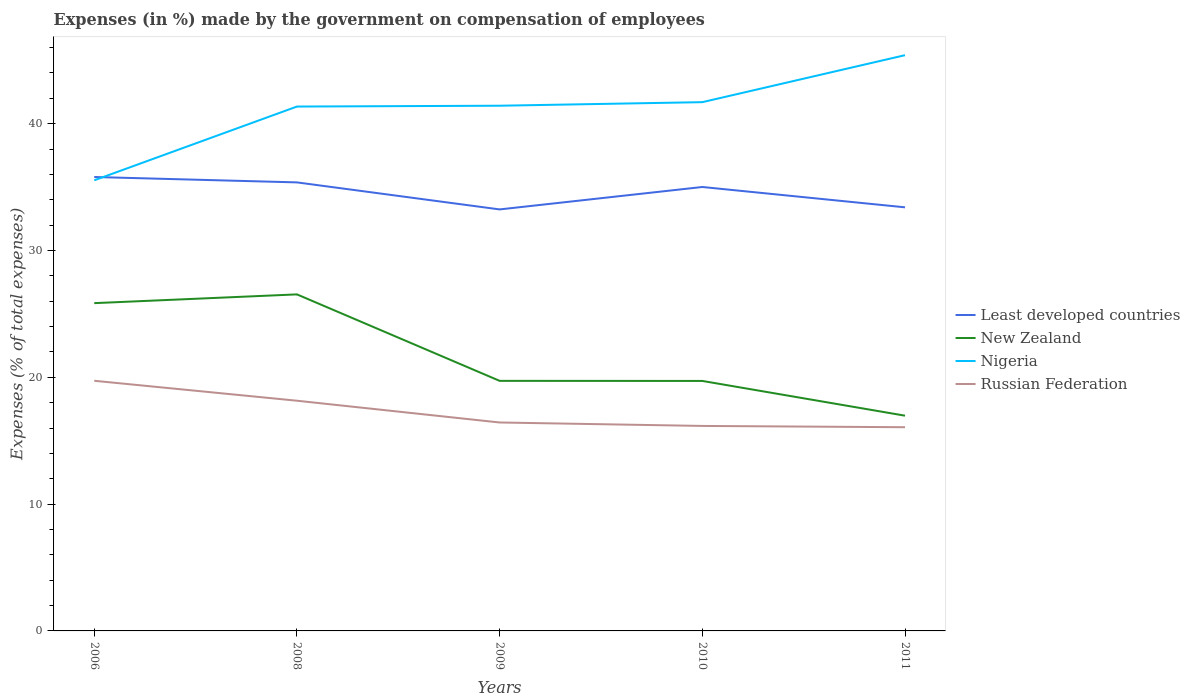How many different coloured lines are there?
Provide a succinct answer. 4. Does the line corresponding to Nigeria intersect with the line corresponding to Russian Federation?
Your answer should be very brief. No. Across all years, what is the maximum percentage of expenses made by the government on compensation of employees in New Zealand?
Your answer should be compact. 16.97. In which year was the percentage of expenses made by the government on compensation of employees in New Zealand maximum?
Offer a terse response. 2011. What is the total percentage of expenses made by the government on compensation of employees in Least developed countries in the graph?
Ensure brevity in your answer.  0.43. What is the difference between the highest and the second highest percentage of expenses made by the government on compensation of employees in Least developed countries?
Ensure brevity in your answer.  2.56. What is the difference between the highest and the lowest percentage of expenses made by the government on compensation of employees in Russian Federation?
Your answer should be compact. 2. Is the percentage of expenses made by the government on compensation of employees in New Zealand strictly greater than the percentage of expenses made by the government on compensation of employees in Russian Federation over the years?
Provide a succinct answer. No. What is the difference between two consecutive major ticks on the Y-axis?
Provide a short and direct response. 10. Are the values on the major ticks of Y-axis written in scientific E-notation?
Give a very brief answer. No. Where does the legend appear in the graph?
Give a very brief answer. Center right. How many legend labels are there?
Provide a succinct answer. 4. How are the legend labels stacked?
Offer a terse response. Vertical. What is the title of the graph?
Your answer should be very brief. Expenses (in %) made by the government on compensation of employees. What is the label or title of the Y-axis?
Keep it short and to the point. Expenses (% of total expenses). What is the Expenses (% of total expenses) in Least developed countries in 2006?
Provide a succinct answer. 35.8. What is the Expenses (% of total expenses) of New Zealand in 2006?
Offer a terse response. 25.85. What is the Expenses (% of total expenses) in Nigeria in 2006?
Your answer should be compact. 35.53. What is the Expenses (% of total expenses) in Russian Federation in 2006?
Provide a succinct answer. 19.73. What is the Expenses (% of total expenses) in Least developed countries in 2008?
Provide a short and direct response. 35.37. What is the Expenses (% of total expenses) in New Zealand in 2008?
Offer a terse response. 26.54. What is the Expenses (% of total expenses) of Nigeria in 2008?
Offer a terse response. 41.35. What is the Expenses (% of total expenses) of Russian Federation in 2008?
Offer a very short reply. 18.15. What is the Expenses (% of total expenses) in Least developed countries in 2009?
Make the answer very short. 33.24. What is the Expenses (% of total expenses) in New Zealand in 2009?
Ensure brevity in your answer.  19.72. What is the Expenses (% of total expenses) of Nigeria in 2009?
Give a very brief answer. 41.42. What is the Expenses (% of total expenses) in Russian Federation in 2009?
Provide a short and direct response. 16.44. What is the Expenses (% of total expenses) of Least developed countries in 2010?
Your answer should be compact. 35.01. What is the Expenses (% of total expenses) of New Zealand in 2010?
Provide a short and direct response. 19.71. What is the Expenses (% of total expenses) of Nigeria in 2010?
Your response must be concise. 41.7. What is the Expenses (% of total expenses) of Russian Federation in 2010?
Your answer should be compact. 16.17. What is the Expenses (% of total expenses) in Least developed countries in 2011?
Offer a terse response. 33.4. What is the Expenses (% of total expenses) of New Zealand in 2011?
Offer a terse response. 16.97. What is the Expenses (% of total expenses) of Nigeria in 2011?
Your answer should be very brief. 45.4. What is the Expenses (% of total expenses) of Russian Federation in 2011?
Offer a terse response. 16.06. Across all years, what is the maximum Expenses (% of total expenses) of Least developed countries?
Keep it short and to the point. 35.8. Across all years, what is the maximum Expenses (% of total expenses) in New Zealand?
Make the answer very short. 26.54. Across all years, what is the maximum Expenses (% of total expenses) of Nigeria?
Your answer should be compact. 45.4. Across all years, what is the maximum Expenses (% of total expenses) in Russian Federation?
Give a very brief answer. 19.73. Across all years, what is the minimum Expenses (% of total expenses) in Least developed countries?
Provide a succinct answer. 33.24. Across all years, what is the minimum Expenses (% of total expenses) of New Zealand?
Your answer should be very brief. 16.97. Across all years, what is the minimum Expenses (% of total expenses) in Nigeria?
Provide a succinct answer. 35.53. Across all years, what is the minimum Expenses (% of total expenses) in Russian Federation?
Ensure brevity in your answer.  16.06. What is the total Expenses (% of total expenses) in Least developed countries in the graph?
Your answer should be very brief. 172.81. What is the total Expenses (% of total expenses) of New Zealand in the graph?
Keep it short and to the point. 108.79. What is the total Expenses (% of total expenses) of Nigeria in the graph?
Offer a very short reply. 205.4. What is the total Expenses (% of total expenses) of Russian Federation in the graph?
Offer a very short reply. 86.54. What is the difference between the Expenses (% of total expenses) in Least developed countries in 2006 and that in 2008?
Ensure brevity in your answer.  0.43. What is the difference between the Expenses (% of total expenses) in New Zealand in 2006 and that in 2008?
Keep it short and to the point. -0.69. What is the difference between the Expenses (% of total expenses) in Nigeria in 2006 and that in 2008?
Provide a succinct answer. -5.82. What is the difference between the Expenses (% of total expenses) in Russian Federation in 2006 and that in 2008?
Make the answer very short. 1.57. What is the difference between the Expenses (% of total expenses) in Least developed countries in 2006 and that in 2009?
Your answer should be very brief. 2.56. What is the difference between the Expenses (% of total expenses) in New Zealand in 2006 and that in 2009?
Ensure brevity in your answer.  6.13. What is the difference between the Expenses (% of total expenses) of Nigeria in 2006 and that in 2009?
Offer a very short reply. -5.88. What is the difference between the Expenses (% of total expenses) in Russian Federation in 2006 and that in 2009?
Provide a short and direct response. 3.29. What is the difference between the Expenses (% of total expenses) in Least developed countries in 2006 and that in 2010?
Offer a terse response. 0.79. What is the difference between the Expenses (% of total expenses) in New Zealand in 2006 and that in 2010?
Your answer should be compact. 6.14. What is the difference between the Expenses (% of total expenses) in Nigeria in 2006 and that in 2010?
Provide a short and direct response. -6.16. What is the difference between the Expenses (% of total expenses) of Russian Federation in 2006 and that in 2010?
Ensure brevity in your answer.  3.56. What is the difference between the Expenses (% of total expenses) in Least developed countries in 2006 and that in 2011?
Your answer should be very brief. 2.39. What is the difference between the Expenses (% of total expenses) in New Zealand in 2006 and that in 2011?
Your response must be concise. 8.88. What is the difference between the Expenses (% of total expenses) in Nigeria in 2006 and that in 2011?
Your answer should be very brief. -9.87. What is the difference between the Expenses (% of total expenses) in Russian Federation in 2006 and that in 2011?
Offer a very short reply. 3.66. What is the difference between the Expenses (% of total expenses) of Least developed countries in 2008 and that in 2009?
Give a very brief answer. 2.13. What is the difference between the Expenses (% of total expenses) in New Zealand in 2008 and that in 2009?
Your response must be concise. 6.82. What is the difference between the Expenses (% of total expenses) of Nigeria in 2008 and that in 2009?
Your answer should be compact. -0.06. What is the difference between the Expenses (% of total expenses) in Russian Federation in 2008 and that in 2009?
Give a very brief answer. 1.72. What is the difference between the Expenses (% of total expenses) of Least developed countries in 2008 and that in 2010?
Your answer should be compact. 0.36. What is the difference between the Expenses (% of total expenses) in New Zealand in 2008 and that in 2010?
Your response must be concise. 6.83. What is the difference between the Expenses (% of total expenses) in Nigeria in 2008 and that in 2010?
Provide a short and direct response. -0.35. What is the difference between the Expenses (% of total expenses) of Russian Federation in 2008 and that in 2010?
Your answer should be very brief. 1.99. What is the difference between the Expenses (% of total expenses) of Least developed countries in 2008 and that in 2011?
Make the answer very short. 1.97. What is the difference between the Expenses (% of total expenses) in New Zealand in 2008 and that in 2011?
Offer a very short reply. 9.57. What is the difference between the Expenses (% of total expenses) in Nigeria in 2008 and that in 2011?
Give a very brief answer. -4.05. What is the difference between the Expenses (% of total expenses) in Russian Federation in 2008 and that in 2011?
Make the answer very short. 2.09. What is the difference between the Expenses (% of total expenses) in Least developed countries in 2009 and that in 2010?
Keep it short and to the point. -1.77. What is the difference between the Expenses (% of total expenses) of New Zealand in 2009 and that in 2010?
Offer a terse response. 0.01. What is the difference between the Expenses (% of total expenses) of Nigeria in 2009 and that in 2010?
Keep it short and to the point. -0.28. What is the difference between the Expenses (% of total expenses) in Russian Federation in 2009 and that in 2010?
Offer a very short reply. 0.27. What is the difference between the Expenses (% of total expenses) of Least developed countries in 2009 and that in 2011?
Provide a short and direct response. -0.17. What is the difference between the Expenses (% of total expenses) in New Zealand in 2009 and that in 2011?
Your answer should be compact. 2.75. What is the difference between the Expenses (% of total expenses) of Nigeria in 2009 and that in 2011?
Give a very brief answer. -3.99. What is the difference between the Expenses (% of total expenses) in Russian Federation in 2009 and that in 2011?
Your response must be concise. 0.37. What is the difference between the Expenses (% of total expenses) of Least developed countries in 2010 and that in 2011?
Offer a terse response. 1.6. What is the difference between the Expenses (% of total expenses) of New Zealand in 2010 and that in 2011?
Offer a terse response. 2.74. What is the difference between the Expenses (% of total expenses) of Nigeria in 2010 and that in 2011?
Your answer should be very brief. -3.7. What is the difference between the Expenses (% of total expenses) in Russian Federation in 2010 and that in 2011?
Offer a very short reply. 0.1. What is the difference between the Expenses (% of total expenses) of Least developed countries in 2006 and the Expenses (% of total expenses) of New Zealand in 2008?
Provide a short and direct response. 9.26. What is the difference between the Expenses (% of total expenses) in Least developed countries in 2006 and the Expenses (% of total expenses) in Nigeria in 2008?
Offer a terse response. -5.56. What is the difference between the Expenses (% of total expenses) of Least developed countries in 2006 and the Expenses (% of total expenses) of Russian Federation in 2008?
Your answer should be very brief. 17.64. What is the difference between the Expenses (% of total expenses) of New Zealand in 2006 and the Expenses (% of total expenses) of Nigeria in 2008?
Your response must be concise. -15.5. What is the difference between the Expenses (% of total expenses) in New Zealand in 2006 and the Expenses (% of total expenses) in Russian Federation in 2008?
Your answer should be very brief. 7.7. What is the difference between the Expenses (% of total expenses) of Nigeria in 2006 and the Expenses (% of total expenses) of Russian Federation in 2008?
Provide a succinct answer. 17.38. What is the difference between the Expenses (% of total expenses) of Least developed countries in 2006 and the Expenses (% of total expenses) of New Zealand in 2009?
Provide a succinct answer. 16.08. What is the difference between the Expenses (% of total expenses) in Least developed countries in 2006 and the Expenses (% of total expenses) in Nigeria in 2009?
Provide a short and direct response. -5.62. What is the difference between the Expenses (% of total expenses) in Least developed countries in 2006 and the Expenses (% of total expenses) in Russian Federation in 2009?
Provide a short and direct response. 19.36. What is the difference between the Expenses (% of total expenses) of New Zealand in 2006 and the Expenses (% of total expenses) of Nigeria in 2009?
Your response must be concise. -15.57. What is the difference between the Expenses (% of total expenses) of New Zealand in 2006 and the Expenses (% of total expenses) of Russian Federation in 2009?
Provide a short and direct response. 9.41. What is the difference between the Expenses (% of total expenses) in Nigeria in 2006 and the Expenses (% of total expenses) in Russian Federation in 2009?
Provide a short and direct response. 19.1. What is the difference between the Expenses (% of total expenses) in Least developed countries in 2006 and the Expenses (% of total expenses) in New Zealand in 2010?
Make the answer very short. 16.08. What is the difference between the Expenses (% of total expenses) in Least developed countries in 2006 and the Expenses (% of total expenses) in Nigeria in 2010?
Your response must be concise. -5.9. What is the difference between the Expenses (% of total expenses) in Least developed countries in 2006 and the Expenses (% of total expenses) in Russian Federation in 2010?
Offer a terse response. 19.63. What is the difference between the Expenses (% of total expenses) of New Zealand in 2006 and the Expenses (% of total expenses) of Nigeria in 2010?
Your answer should be compact. -15.85. What is the difference between the Expenses (% of total expenses) in New Zealand in 2006 and the Expenses (% of total expenses) in Russian Federation in 2010?
Provide a succinct answer. 9.68. What is the difference between the Expenses (% of total expenses) of Nigeria in 2006 and the Expenses (% of total expenses) of Russian Federation in 2010?
Your answer should be very brief. 19.37. What is the difference between the Expenses (% of total expenses) of Least developed countries in 2006 and the Expenses (% of total expenses) of New Zealand in 2011?
Offer a terse response. 18.82. What is the difference between the Expenses (% of total expenses) of Least developed countries in 2006 and the Expenses (% of total expenses) of Nigeria in 2011?
Your answer should be very brief. -9.61. What is the difference between the Expenses (% of total expenses) of Least developed countries in 2006 and the Expenses (% of total expenses) of Russian Federation in 2011?
Offer a terse response. 19.73. What is the difference between the Expenses (% of total expenses) in New Zealand in 2006 and the Expenses (% of total expenses) in Nigeria in 2011?
Ensure brevity in your answer.  -19.55. What is the difference between the Expenses (% of total expenses) of New Zealand in 2006 and the Expenses (% of total expenses) of Russian Federation in 2011?
Give a very brief answer. 9.79. What is the difference between the Expenses (% of total expenses) of Nigeria in 2006 and the Expenses (% of total expenses) of Russian Federation in 2011?
Provide a short and direct response. 19.47. What is the difference between the Expenses (% of total expenses) of Least developed countries in 2008 and the Expenses (% of total expenses) of New Zealand in 2009?
Ensure brevity in your answer.  15.65. What is the difference between the Expenses (% of total expenses) of Least developed countries in 2008 and the Expenses (% of total expenses) of Nigeria in 2009?
Make the answer very short. -6.05. What is the difference between the Expenses (% of total expenses) of Least developed countries in 2008 and the Expenses (% of total expenses) of Russian Federation in 2009?
Your response must be concise. 18.93. What is the difference between the Expenses (% of total expenses) in New Zealand in 2008 and the Expenses (% of total expenses) in Nigeria in 2009?
Your response must be concise. -14.88. What is the difference between the Expenses (% of total expenses) in New Zealand in 2008 and the Expenses (% of total expenses) in Russian Federation in 2009?
Give a very brief answer. 10.1. What is the difference between the Expenses (% of total expenses) of Nigeria in 2008 and the Expenses (% of total expenses) of Russian Federation in 2009?
Your answer should be very brief. 24.91. What is the difference between the Expenses (% of total expenses) in Least developed countries in 2008 and the Expenses (% of total expenses) in New Zealand in 2010?
Your answer should be compact. 15.66. What is the difference between the Expenses (% of total expenses) in Least developed countries in 2008 and the Expenses (% of total expenses) in Nigeria in 2010?
Ensure brevity in your answer.  -6.33. What is the difference between the Expenses (% of total expenses) in Least developed countries in 2008 and the Expenses (% of total expenses) in Russian Federation in 2010?
Provide a succinct answer. 19.2. What is the difference between the Expenses (% of total expenses) of New Zealand in 2008 and the Expenses (% of total expenses) of Nigeria in 2010?
Give a very brief answer. -15.16. What is the difference between the Expenses (% of total expenses) in New Zealand in 2008 and the Expenses (% of total expenses) in Russian Federation in 2010?
Your answer should be compact. 10.37. What is the difference between the Expenses (% of total expenses) in Nigeria in 2008 and the Expenses (% of total expenses) in Russian Federation in 2010?
Offer a terse response. 25.19. What is the difference between the Expenses (% of total expenses) in Least developed countries in 2008 and the Expenses (% of total expenses) in New Zealand in 2011?
Offer a very short reply. 18.4. What is the difference between the Expenses (% of total expenses) of Least developed countries in 2008 and the Expenses (% of total expenses) of Nigeria in 2011?
Make the answer very short. -10.03. What is the difference between the Expenses (% of total expenses) in Least developed countries in 2008 and the Expenses (% of total expenses) in Russian Federation in 2011?
Your answer should be very brief. 19.31. What is the difference between the Expenses (% of total expenses) in New Zealand in 2008 and the Expenses (% of total expenses) in Nigeria in 2011?
Your answer should be compact. -18.86. What is the difference between the Expenses (% of total expenses) of New Zealand in 2008 and the Expenses (% of total expenses) of Russian Federation in 2011?
Provide a succinct answer. 10.47. What is the difference between the Expenses (% of total expenses) of Nigeria in 2008 and the Expenses (% of total expenses) of Russian Federation in 2011?
Provide a succinct answer. 25.29. What is the difference between the Expenses (% of total expenses) of Least developed countries in 2009 and the Expenses (% of total expenses) of New Zealand in 2010?
Your response must be concise. 13.53. What is the difference between the Expenses (% of total expenses) of Least developed countries in 2009 and the Expenses (% of total expenses) of Nigeria in 2010?
Your response must be concise. -8.46. What is the difference between the Expenses (% of total expenses) of Least developed countries in 2009 and the Expenses (% of total expenses) of Russian Federation in 2010?
Your response must be concise. 17.07. What is the difference between the Expenses (% of total expenses) in New Zealand in 2009 and the Expenses (% of total expenses) in Nigeria in 2010?
Your response must be concise. -21.98. What is the difference between the Expenses (% of total expenses) of New Zealand in 2009 and the Expenses (% of total expenses) of Russian Federation in 2010?
Your answer should be compact. 3.55. What is the difference between the Expenses (% of total expenses) in Nigeria in 2009 and the Expenses (% of total expenses) in Russian Federation in 2010?
Keep it short and to the point. 25.25. What is the difference between the Expenses (% of total expenses) of Least developed countries in 2009 and the Expenses (% of total expenses) of New Zealand in 2011?
Your answer should be very brief. 16.27. What is the difference between the Expenses (% of total expenses) of Least developed countries in 2009 and the Expenses (% of total expenses) of Nigeria in 2011?
Keep it short and to the point. -12.16. What is the difference between the Expenses (% of total expenses) of Least developed countries in 2009 and the Expenses (% of total expenses) of Russian Federation in 2011?
Your answer should be compact. 17.18. What is the difference between the Expenses (% of total expenses) in New Zealand in 2009 and the Expenses (% of total expenses) in Nigeria in 2011?
Your answer should be very brief. -25.68. What is the difference between the Expenses (% of total expenses) of New Zealand in 2009 and the Expenses (% of total expenses) of Russian Federation in 2011?
Your answer should be compact. 3.66. What is the difference between the Expenses (% of total expenses) in Nigeria in 2009 and the Expenses (% of total expenses) in Russian Federation in 2011?
Provide a short and direct response. 25.35. What is the difference between the Expenses (% of total expenses) of Least developed countries in 2010 and the Expenses (% of total expenses) of New Zealand in 2011?
Keep it short and to the point. 18.03. What is the difference between the Expenses (% of total expenses) in Least developed countries in 2010 and the Expenses (% of total expenses) in Nigeria in 2011?
Provide a succinct answer. -10.39. What is the difference between the Expenses (% of total expenses) of Least developed countries in 2010 and the Expenses (% of total expenses) of Russian Federation in 2011?
Your answer should be very brief. 18.94. What is the difference between the Expenses (% of total expenses) in New Zealand in 2010 and the Expenses (% of total expenses) in Nigeria in 2011?
Give a very brief answer. -25.69. What is the difference between the Expenses (% of total expenses) of New Zealand in 2010 and the Expenses (% of total expenses) of Russian Federation in 2011?
Keep it short and to the point. 3.65. What is the difference between the Expenses (% of total expenses) in Nigeria in 2010 and the Expenses (% of total expenses) in Russian Federation in 2011?
Give a very brief answer. 25.63. What is the average Expenses (% of total expenses) of Least developed countries per year?
Make the answer very short. 34.56. What is the average Expenses (% of total expenses) of New Zealand per year?
Your response must be concise. 21.76. What is the average Expenses (% of total expenses) in Nigeria per year?
Offer a very short reply. 41.08. What is the average Expenses (% of total expenses) in Russian Federation per year?
Your answer should be compact. 17.31. In the year 2006, what is the difference between the Expenses (% of total expenses) in Least developed countries and Expenses (% of total expenses) in New Zealand?
Your response must be concise. 9.95. In the year 2006, what is the difference between the Expenses (% of total expenses) in Least developed countries and Expenses (% of total expenses) in Nigeria?
Offer a terse response. 0.26. In the year 2006, what is the difference between the Expenses (% of total expenses) in Least developed countries and Expenses (% of total expenses) in Russian Federation?
Your answer should be compact. 16.07. In the year 2006, what is the difference between the Expenses (% of total expenses) of New Zealand and Expenses (% of total expenses) of Nigeria?
Ensure brevity in your answer.  -9.69. In the year 2006, what is the difference between the Expenses (% of total expenses) in New Zealand and Expenses (% of total expenses) in Russian Federation?
Make the answer very short. 6.12. In the year 2006, what is the difference between the Expenses (% of total expenses) of Nigeria and Expenses (% of total expenses) of Russian Federation?
Ensure brevity in your answer.  15.81. In the year 2008, what is the difference between the Expenses (% of total expenses) in Least developed countries and Expenses (% of total expenses) in New Zealand?
Offer a very short reply. 8.83. In the year 2008, what is the difference between the Expenses (% of total expenses) of Least developed countries and Expenses (% of total expenses) of Nigeria?
Offer a very short reply. -5.98. In the year 2008, what is the difference between the Expenses (% of total expenses) of Least developed countries and Expenses (% of total expenses) of Russian Federation?
Your response must be concise. 17.22. In the year 2008, what is the difference between the Expenses (% of total expenses) of New Zealand and Expenses (% of total expenses) of Nigeria?
Provide a short and direct response. -14.81. In the year 2008, what is the difference between the Expenses (% of total expenses) in New Zealand and Expenses (% of total expenses) in Russian Federation?
Your answer should be compact. 8.39. In the year 2008, what is the difference between the Expenses (% of total expenses) in Nigeria and Expenses (% of total expenses) in Russian Federation?
Offer a very short reply. 23.2. In the year 2009, what is the difference between the Expenses (% of total expenses) in Least developed countries and Expenses (% of total expenses) in New Zealand?
Provide a short and direct response. 13.52. In the year 2009, what is the difference between the Expenses (% of total expenses) of Least developed countries and Expenses (% of total expenses) of Nigeria?
Keep it short and to the point. -8.18. In the year 2009, what is the difference between the Expenses (% of total expenses) of Least developed countries and Expenses (% of total expenses) of Russian Federation?
Ensure brevity in your answer.  16.8. In the year 2009, what is the difference between the Expenses (% of total expenses) of New Zealand and Expenses (% of total expenses) of Nigeria?
Ensure brevity in your answer.  -21.7. In the year 2009, what is the difference between the Expenses (% of total expenses) of New Zealand and Expenses (% of total expenses) of Russian Federation?
Your answer should be compact. 3.28. In the year 2009, what is the difference between the Expenses (% of total expenses) of Nigeria and Expenses (% of total expenses) of Russian Federation?
Make the answer very short. 24.98. In the year 2010, what is the difference between the Expenses (% of total expenses) of Least developed countries and Expenses (% of total expenses) of New Zealand?
Make the answer very short. 15.29. In the year 2010, what is the difference between the Expenses (% of total expenses) in Least developed countries and Expenses (% of total expenses) in Nigeria?
Make the answer very short. -6.69. In the year 2010, what is the difference between the Expenses (% of total expenses) in Least developed countries and Expenses (% of total expenses) in Russian Federation?
Provide a succinct answer. 18.84. In the year 2010, what is the difference between the Expenses (% of total expenses) in New Zealand and Expenses (% of total expenses) in Nigeria?
Offer a very short reply. -21.98. In the year 2010, what is the difference between the Expenses (% of total expenses) in New Zealand and Expenses (% of total expenses) in Russian Federation?
Keep it short and to the point. 3.55. In the year 2010, what is the difference between the Expenses (% of total expenses) in Nigeria and Expenses (% of total expenses) in Russian Federation?
Give a very brief answer. 25.53. In the year 2011, what is the difference between the Expenses (% of total expenses) of Least developed countries and Expenses (% of total expenses) of New Zealand?
Keep it short and to the point. 16.43. In the year 2011, what is the difference between the Expenses (% of total expenses) in Least developed countries and Expenses (% of total expenses) in Nigeria?
Make the answer very short. -12. In the year 2011, what is the difference between the Expenses (% of total expenses) in Least developed countries and Expenses (% of total expenses) in Russian Federation?
Your response must be concise. 17.34. In the year 2011, what is the difference between the Expenses (% of total expenses) in New Zealand and Expenses (% of total expenses) in Nigeria?
Make the answer very short. -28.43. In the year 2011, what is the difference between the Expenses (% of total expenses) of New Zealand and Expenses (% of total expenses) of Russian Federation?
Your response must be concise. 0.91. In the year 2011, what is the difference between the Expenses (% of total expenses) of Nigeria and Expenses (% of total expenses) of Russian Federation?
Provide a short and direct response. 29.34. What is the ratio of the Expenses (% of total expenses) in Least developed countries in 2006 to that in 2008?
Your answer should be very brief. 1.01. What is the ratio of the Expenses (% of total expenses) of New Zealand in 2006 to that in 2008?
Offer a very short reply. 0.97. What is the ratio of the Expenses (% of total expenses) in Nigeria in 2006 to that in 2008?
Provide a short and direct response. 0.86. What is the ratio of the Expenses (% of total expenses) in Russian Federation in 2006 to that in 2008?
Make the answer very short. 1.09. What is the ratio of the Expenses (% of total expenses) in Least developed countries in 2006 to that in 2009?
Keep it short and to the point. 1.08. What is the ratio of the Expenses (% of total expenses) of New Zealand in 2006 to that in 2009?
Ensure brevity in your answer.  1.31. What is the ratio of the Expenses (% of total expenses) of Nigeria in 2006 to that in 2009?
Your response must be concise. 0.86. What is the ratio of the Expenses (% of total expenses) of Russian Federation in 2006 to that in 2009?
Offer a terse response. 1.2. What is the ratio of the Expenses (% of total expenses) of Least developed countries in 2006 to that in 2010?
Your answer should be very brief. 1.02. What is the ratio of the Expenses (% of total expenses) in New Zealand in 2006 to that in 2010?
Provide a succinct answer. 1.31. What is the ratio of the Expenses (% of total expenses) in Nigeria in 2006 to that in 2010?
Offer a very short reply. 0.85. What is the ratio of the Expenses (% of total expenses) in Russian Federation in 2006 to that in 2010?
Ensure brevity in your answer.  1.22. What is the ratio of the Expenses (% of total expenses) of Least developed countries in 2006 to that in 2011?
Offer a very short reply. 1.07. What is the ratio of the Expenses (% of total expenses) of New Zealand in 2006 to that in 2011?
Make the answer very short. 1.52. What is the ratio of the Expenses (% of total expenses) in Nigeria in 2006 to that in 2011?
Offer a very short reply. 0.78. What is the ratio of the Expenses (% of total expenses) in Russian Federation in 2006 to that in 2011?
Provide a succinct answer. 1.23. What is the ratio of the Expenses (% of total expenses) of Least developed countries in 2008 to that in 2009?
Your response must be concise. 1.06. What is the ratio of the Expenses (% of total expenses) in New Zealand in 2008 to that in 2009?
Offer a very short reply. 1.35. What is the ratio of the Expenses (% of total expenses) in Nigeria in 2008 to that in 2009?
Make the answer very short. 1. What is the ratio of the Expenses (% of total expenses) in Russian Federation in 2008 to that in 2009?
Offer a terse response. 1.1. What is the ratio of the Expenses (% of total expenses) in Least developed countries in 2008 to that in 2010?
Offer a terse response. 1.01. What is the ratio of the Expenses (% of total expenses) in New Zealand in 2008 to that in 2010?
Your answer should be very brief. 1.35. What is the ratio of the Expenses (% of total expenses) in Russian Federation in 2008 to that in 2010?
Your answer should be very brief. 1.12. What is the ratio of the Expenses (% of total expenses) of Least developed countries in 2008 to that in 2011?
Provide a short and direct response. 1.06. What is the ratio of the Expenses (% of total expenses) in New Zealand in 2008 to that in 2011?
Your answer should be compact. 1.56. What is the ratio of the Expenses (% of total expenses) in Nigeria in 2008 to that in 2011?
Offer a terse response. 0.91. What is the ratio of the Expenses (% of total expenses) in Russian Federation in 2008 to that in 2011?
Offer a terse response. 1.13. What is the ratio of the Expenses (% of total expenses) of Least developed countries in 2009 to that in 2010?
Make the answer very short. 0.95. What is the ratio of the Expenses (% of total expenses) of New Zealand in 2009 to that in 2010?
Give a very brief answer. 1. What is the ratio of the Expenses (% of total expenses) in Russian Federation in 2009 to that in 2010?
Your answer should be compact. 1.02. What is the ratio of the Expenses (% of total expenses) of New Zealand in 2009 to that in 2011?
Give a very brief answer. 1.16. What is the ratio of the Expenses (% of total expenses) in Nigeria in 2009 to that in 2011?
Give a very brief answer. 0.91. What is the ratio of the Expenses (% of total expenses) in Russian Federation in 2009 to that in 2011?
Offer a terse response. 1.02. What is the ratio of the Expenses (% of total expenses) in Least developed countries in 2010 to that in 2011?
Your answer should be compact. 1.05. What is the ratio of the Expenses (% of total expenses) of New Zealand in 2010 to that in 2011?
Keep it short and to the point. 1.16. What is the ratio of the Expenses (% of total expenses) in Nigeria in 2010 to that in 2011?
Give a very brief answer. 0.92. What is the ratio of the Expenses (% of total expenses) in Russian Federation in 2010 to that in 2011?
Offer a terse response. 1.01. What is the difference between the highest and the second highest Expenses (% of total expenses) of Least developed countries?
Provide a succinct answer. 0.43. What is the difference between the highest and the second highest Expenses (% of total expenses) in New Zealand?
Offer a terse response. 0.69. What is the difference between the highest and the second highest Expenses (% of total expenses) in Nigeria?
Offer a terse response. 3.7. What is the difference between the highest and the second highest Expenses (% of total expenses) in Russian Federation?
Provide a succinct answer. 1.57. What is the difference between the highest and the lowest Expenses (% of total expenses) of Least developed countries?
Your answer should be very brief. 2.56. What is the difference between the highest and the lowest Expenses (% of total expenses) in New Zealand?
Offer a very short reply. 9.57. What is the difference between the highest and the lowest Expenses (% of total expenses) of Nigeria?
Ensure brevity in your answer.  9.87. What is the difference between the highest and the lowest Expenses (% of total expenses) of Russian Federation?
Your answer should be compact. 3.66. 